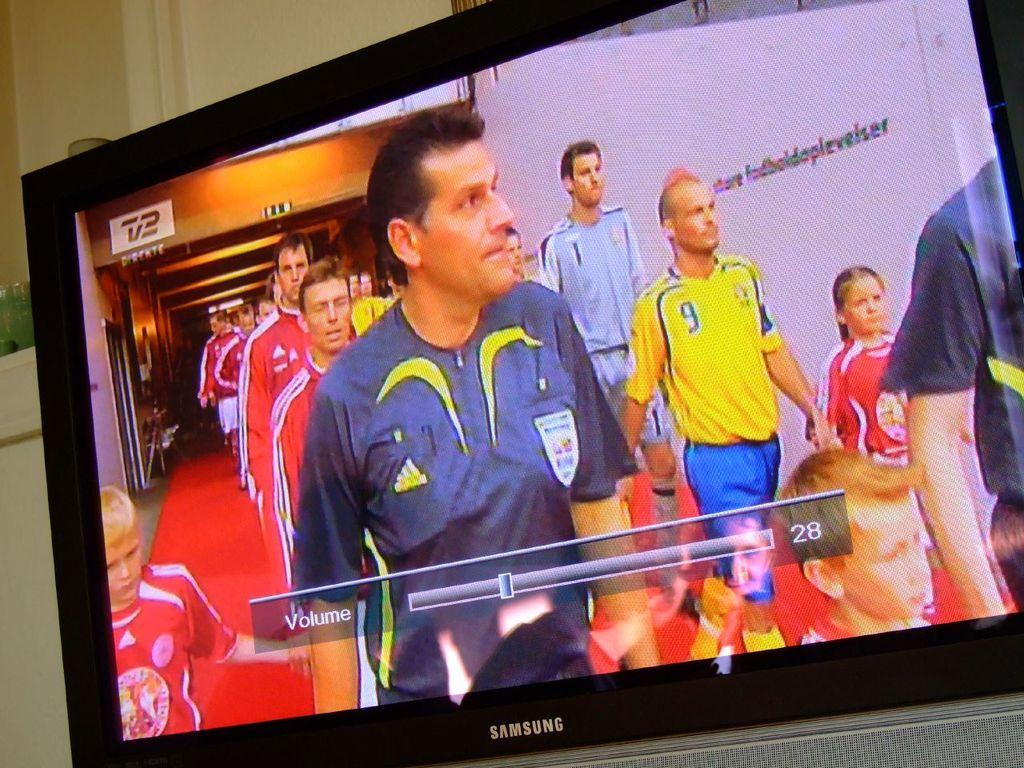<image>
Share a concise interpretation of the image provided. The volume is adjusted on a tv while a game plays. 